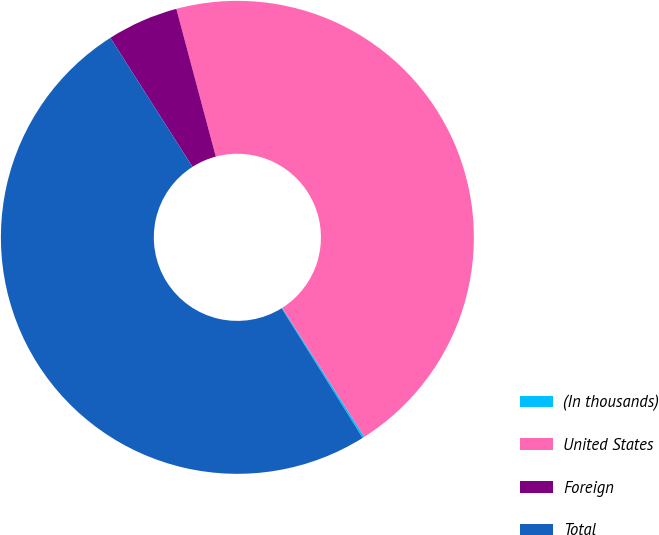<chart> <loc_0><loc_0><loc_500><loc_500><pie_chart><fcel>(In thousands)<fcel>United States<fcel>Foreign<fcel>Total<nl><fcel>0.14%<fcel>45.13%<fcel>4.87%<fcel>49.86%<nl></chart> 